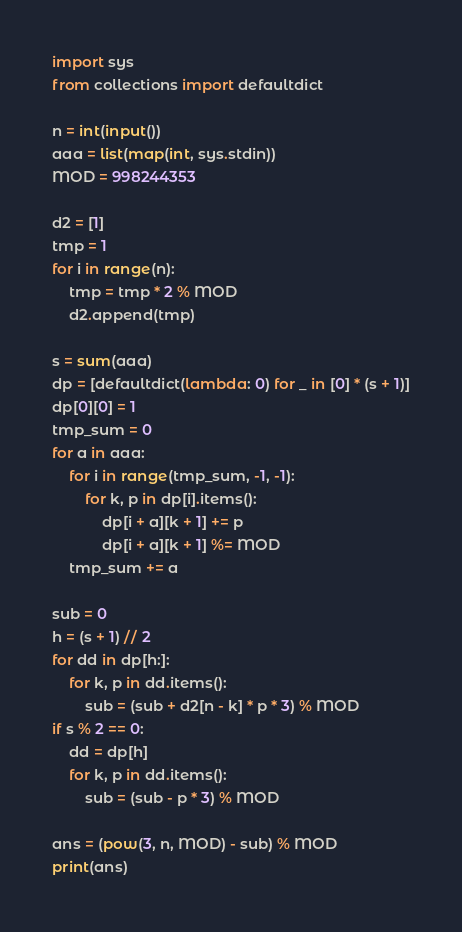<code> <loc_0><loc_0><loc_500><loc_500><_Python_>import sys
from collections import defaultdict

n = int(input())
aaa = list(map(int, sys.stdin))
MOD = 998244353

d2 = [1]
tmp = 1
for i in range(n):
    tmp = tmp * 2 % MOD
    d2.append(tmp)

s = sum(aaa)
dp = [defaultdict(lambda: 0) for _ in [0] * (s + 1)]
dp[0][0] = 1
tmp_sum = 0
for a in aaa:
    for i in range(tmp_sum, -1, -1):
        for k, p in dp[i].items():
            dp[i + a][k + 1] += p
            dp[i + a][k + 1] %= MOD
    tmp_sum += a

sub = 0
h = (s + 1) // 2
for dd in dp[h:]:
    for k, p in dd.items():
        sub = (sub + d2[n - k] * p * 3) % MOD
if s % 2 == 0:
    dd = dp[h]
    for k, p in dd.items():
        sub = (sub - p * 3) % MOD

ans = (pow(3, n, MOD) - sub) % MOD
print(ans)
</code> 